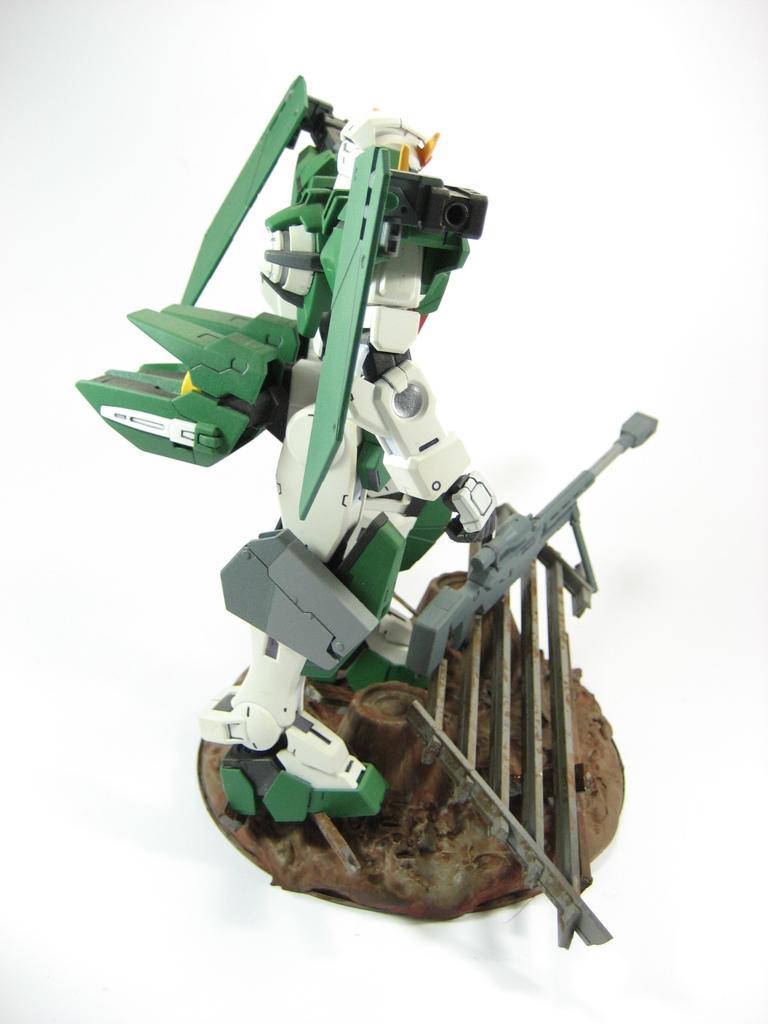Could you give a brief overview of what you see in this image? In this image I can see the robot toy which is white, green, grey, black and brown in color. I can see the white colored background. 